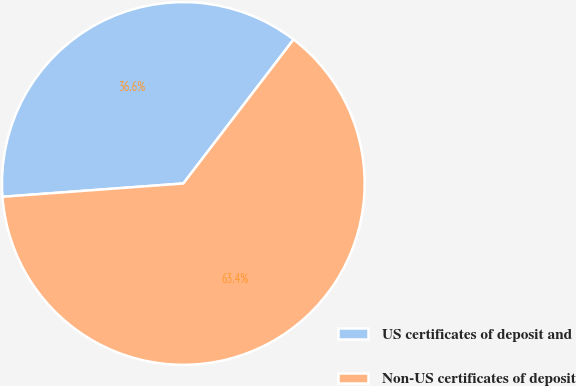Convert chart to OTSL. <chart><loc_0><loc_0><loc_500><loc_500><pie_chart><fcel>US certificates of deposit and<fcel>Non-US certificates of deposit<nl><fcel>36.57%<fcel>63.43%<nl></chart> 